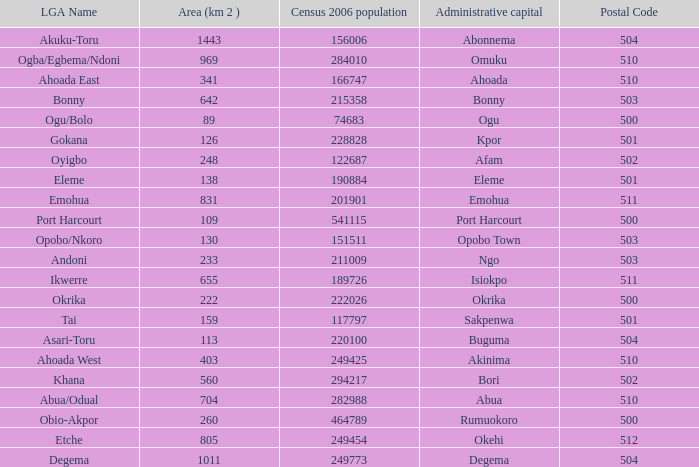What is the postal code when the administrative capital in Bori? 502.0. 